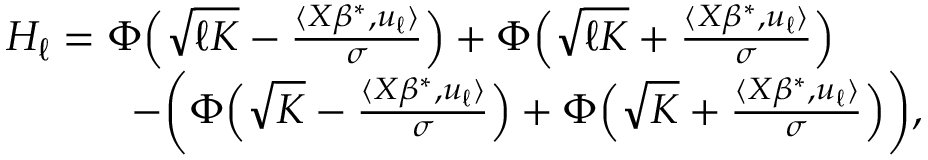<formula> <loc_0><loc_0><loc_500><loc_500>\begin{array} { r l } & { H _ { \ell } = \Phi \left ( \sqrt { \ell K } - \frac { \langle X \beta ^ { * } , u _ { \ell } \rangle } { \sigma } \right ) + \Phi \left ( \sqrt { \ell K } + \frac { \langle X \beta ^ { * } , u _ { \ell } \rangle } { \sigma } \right ) } \\ & { \quad - \left ( \Phi \left ( \sqrt { K } - \frac { \langle X \beta ^ { * } , u _ { \ell } \rangle } { \sigma } \right ) + \Phi \left ( \sqrt { K } + \frac { \langle X \beta ^ { * } , u _ { \ell } \rangle } { \sigma } \right ) \right ) , } \end{array}</formula> 